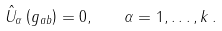Convert formula to latex. <formula><loc_0><loc_0><loc_500><loc_500>\hat { U } _ { \alpha } \left ( g _ { a b } \right ) = 0 , \quad \alpha = 1 , \dots , k \, .</formula> 